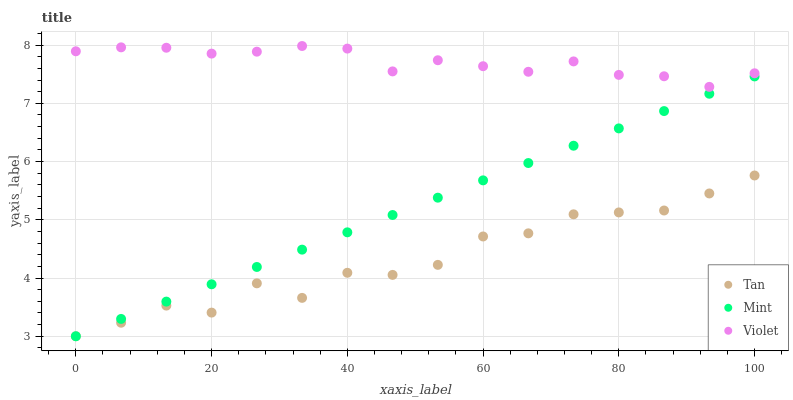Does Tan have the minimum area under the curve?
Answer yes or no. Yes. Does Violet have the maximum area under the curve?
Answer yes or no. Yes. Does Mint have the minimum area under the curve?
Answer yes or no. No. Does Mint have the maximum area under the curve?
Answer yes or no. No. Is Mint the smoothest?
Answer yes or no. Yes. Is Tan the roughest?
Answer yes or no. Yes. Is Violet the smoothest?
Answer yes or no. No. Is Violet the roughest?
Answer yes or no. No. Does Tan have the lowest value?
Answer yes or no. Yes. Does Violet have the lowest value?
Answer yes or no. No. Does Violet have the highest value?
Answer yes or no. Yes. Does Mint have the highest value?
Answer yes or no. No. Is Mint less than Violet?
Answer yes or no. Yes. Is Violet greater than Tan?
Answer yes or no. Yes. Does Mint intersect Tan?
Answer yes or no. Yes. Is Mint less than Tan?
Answer yes or no. No. Is Mint greater than Tan?
Answer yes or no. No. Does Mint intersect Violet?
Answer yes or no. No. 